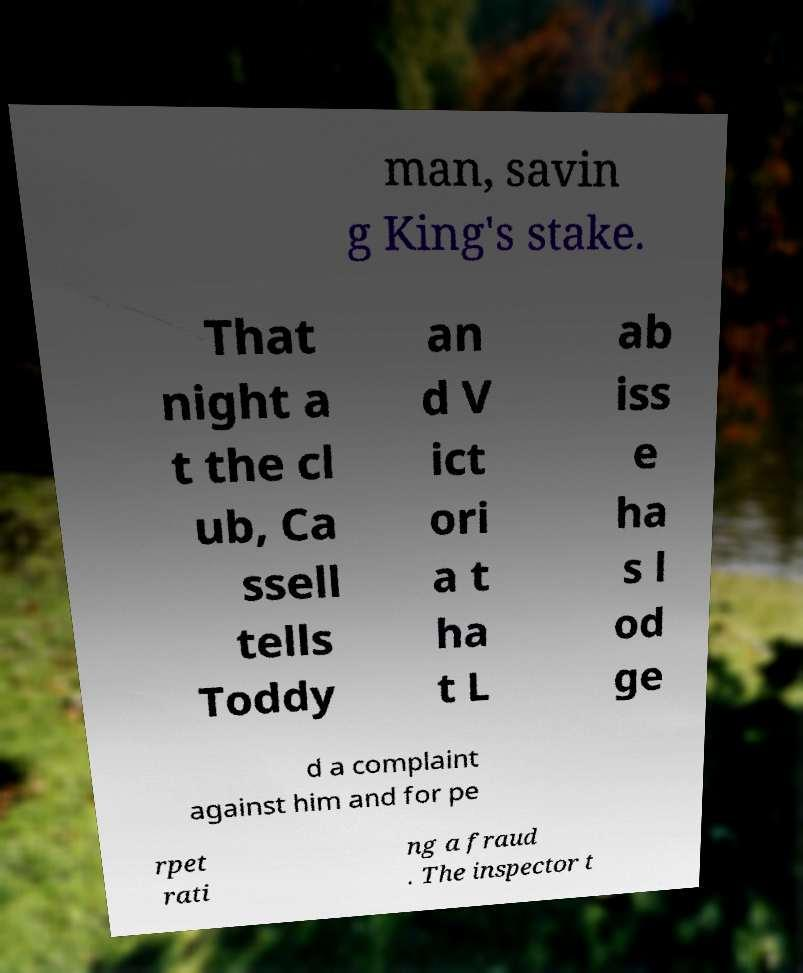Could you assist in decoding the text presented in this image and type it out clearly? man, savin g King's stake. That night a t the cl ub, Ca ssell tells Toddy an d V ict ori a t ha t L ab iss e ha s l od ge d a complaint against him and for pe rpet rati ng a fraud . The inspector t 